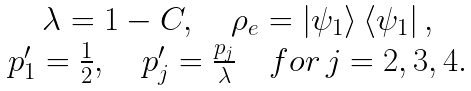Convert formula to latex. <formula><loc_0><loc_0><loc_500><loc_500>\begin{array} { c } \lambda = 1 - C , \quad \rho _ { e } = \left | \psi _ { 1 } \right > \left < \psi _ { 1 } \right | , \\ p _ { 1 } ^ { \prime } = \frac { 1 } { 2 } , \quad p _ { j } ^ { \prime } = \frac { p _ { j } } { \lambda } \quad f o r \, j = 2 , 3 , 4 . \end{array}</formula> 